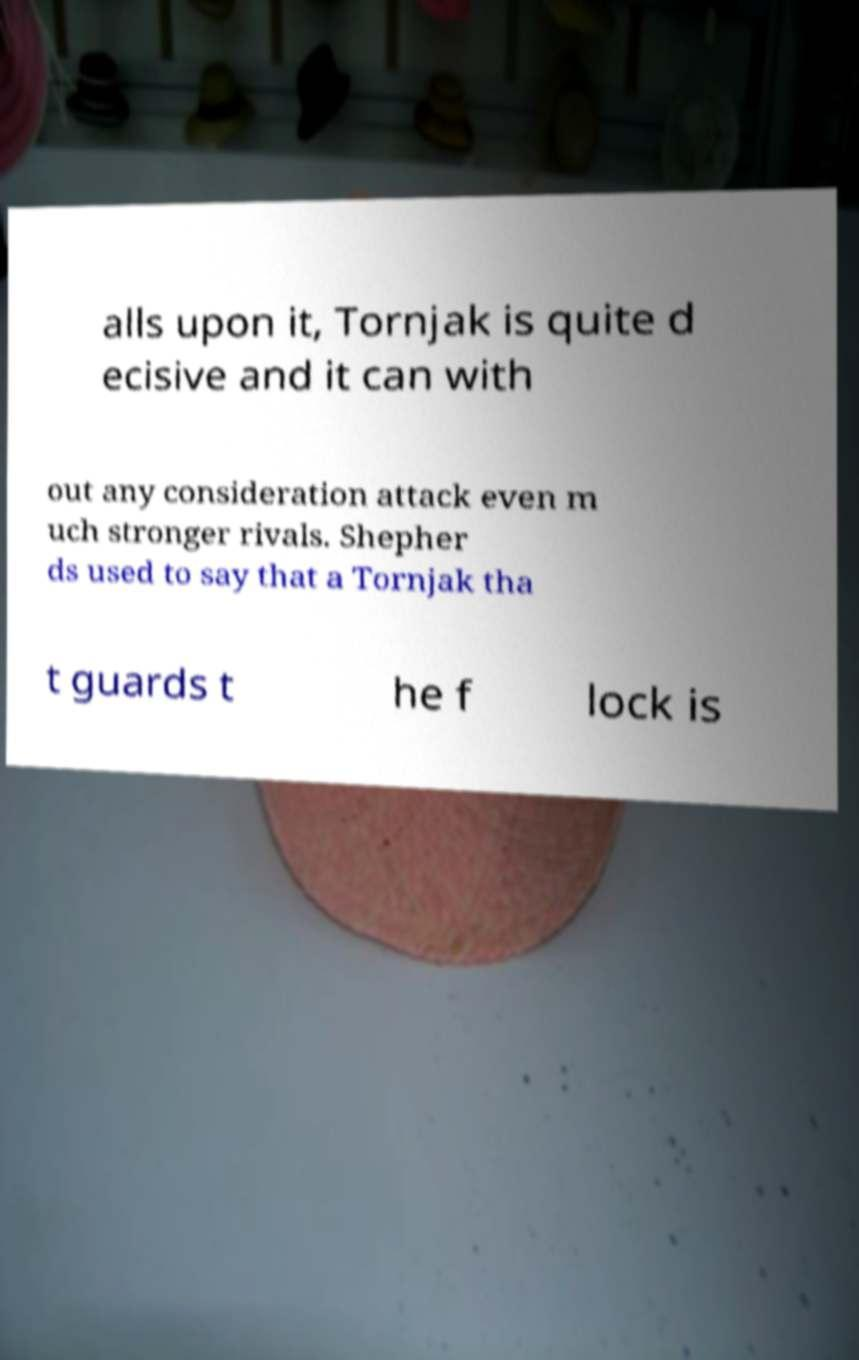Can you read and provide the text displayed in the image?This photo seems to have some interesting text. Can you extract and type it out for me? alls upon it, Tornjak is quite d ecisive and it can with out any consideration attack even m uch stronger rivals. Shepher ds used to say that a Tornjak tha t guards t he f lock is 